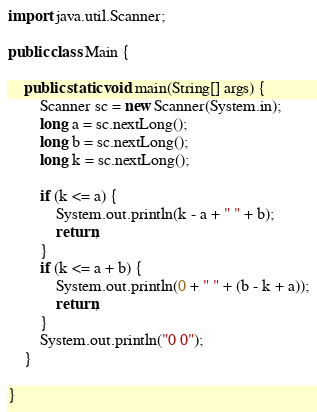Convert code to text. <code><loc_0><loc_0><loc_500><loc_500><_Java_>
import java.util.Scanner;

public class Main {

	public static void main(String[] args) {
		Scanner sc = new Scanner(System.in);
		long a = sc.nextLong();
		long b = sc.nextLong();
		long k = sc.nextLong();

		if (k <= a) {
			System.out.println(k - a + " " + b);
			return;
		}
		if (k <= a + b) {
			System.out.println(0 + " " + (b - k + a));
			return;
		}
		System.out.println("0 0");
	}

}</code> 